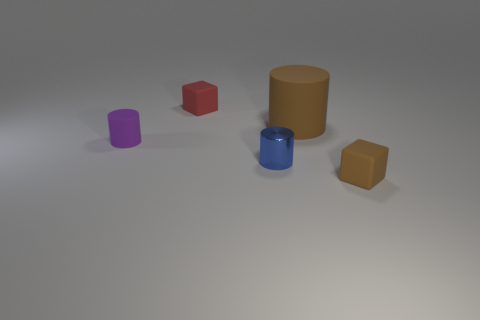Add 3 red matte things. How many objects exist? 8 Subtract all purple cubes. Subtract all blue cylinders. How many cubes are left? 2 Subtract all cylinders. How many objects are left? 2 Add 1 tiny brown things. How many tiny brown things are left? 2 Add 3 tiny brown rubber things. How many tiny brown rubber things exist? 4 Subtract 0 yellow balls. How many objects are left? 5 Subtract all tiny blue cylinders. Subtract all large rubber things. How many objects are left? 3 